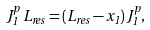<formula> <loc_0><loc_0><loc_500><loc_500>J _ { 1 } ^ { p } \, L _ { r e s } = ( L _ { r e s } - x _ { 1 } ) \, J _ { 1 } ^ { p } ,</formula> 